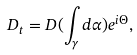<formula> <loc_0><loc_0><loc_500><loc_500>D _ { t } = D ( \int _ { \gamma } d \alpha ) e ^ { i \Theta } ,</formula> 